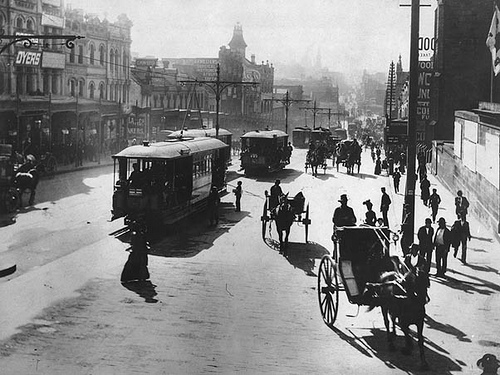Read and extract the text from this image. DYERS 001 NC INI 